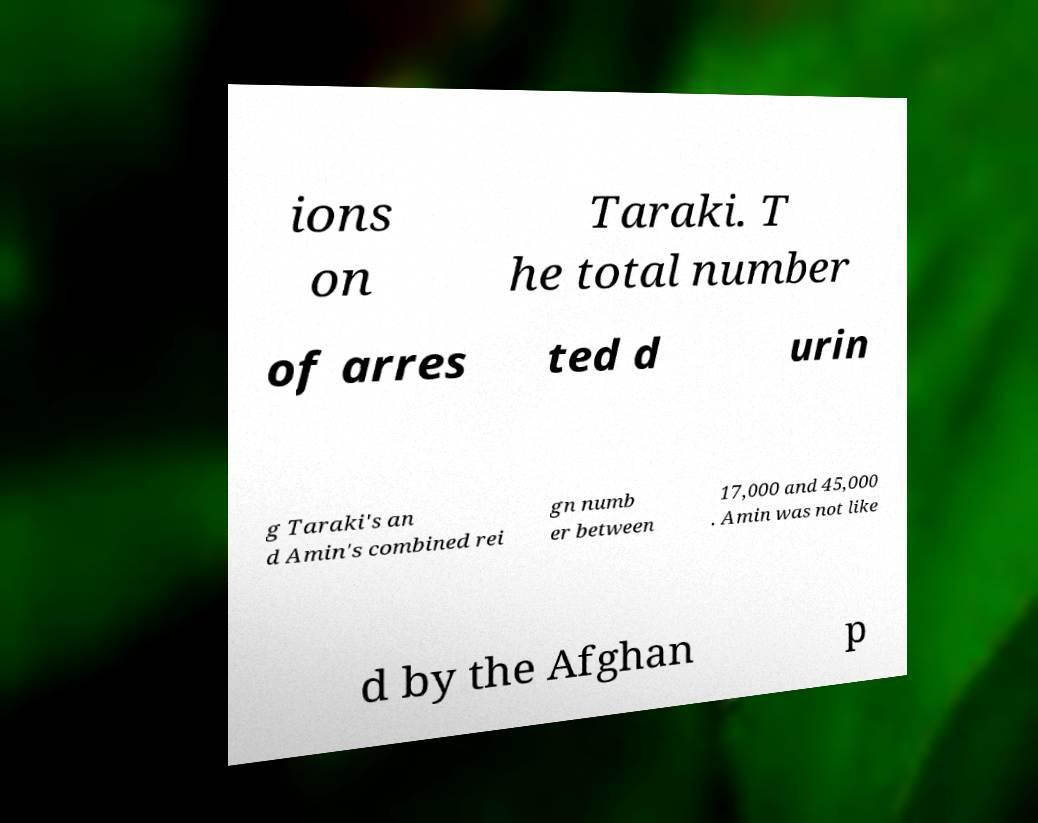Could you assist in decoding the text presented in this image and type it out clearly? ions on Taraki. T he total number of arres ted d urin g Taraki's an d Amin's combined rei gn numb er between 17,000 and 45,000 . Amin was not like d by the Afghan p 